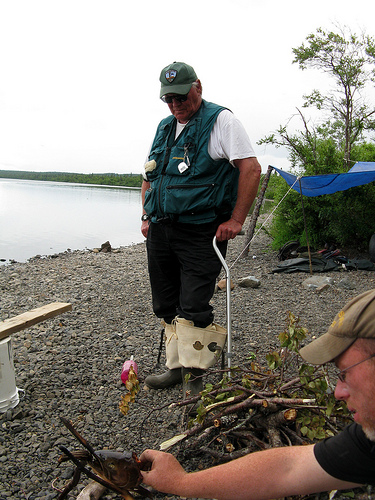<image>
Is there a cane on the shoe? No. The cane is not positioned on the shoe. They may be near each other, but the cane is not supported by or resting on top of the shoe. Is the tent behind the man? Yes. From this viewpoint, the tent is positioned behind the man, with the man partially or fully occluding the tent. Where is the boot air in relation to the wood air? Is it next to the wood air? No. The boot air is not positioned next to the wood air. They are located in different areas of the scene. 